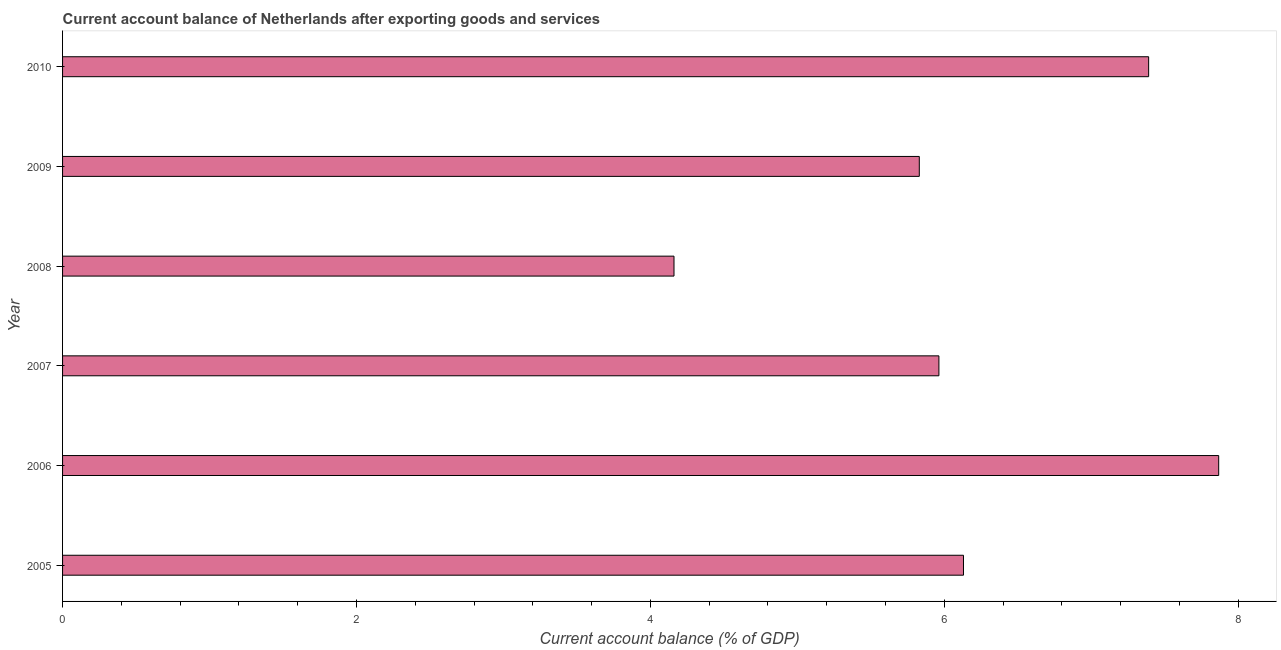What is the title of the graph?
Make the answer very short. Current account balance of Netherlands after exporting goods and services. What is the label or title of the X-axis?
Give a very brief answer. Current account balance (% of GDP). What is the label or title of the Y-axis?
Offer a terse response. Year. What is the current account balance in 2007?
Provide a succinct answer. 5.96. Across all years, what is the maximum current account balance?
Your answer should be very brief. 7.87. Across all years, what is the minimum current account balance?
Your answer should be very brief. 4.16. What is the sum of the current account balance?
Your response must be concise. 37.34. What is the difference between the current account balance in 2006 and 2008?
Offer a very short reply. 3.71. What is the average current account balance per year?
Your answer should be compact. 6.22. What is the median current account balance?
Your answer should be compact. 6.05. In how many years, is the current account balance greater than 5.6 %?
Your answer should be compact. 5. What is the ratio of the current account balance in 2005 to that in 2010?
Ensure brevity in your answer.  0.83. Is the current account balance in 2005 less than that in 2008?
Offer a very short reply. No. What is the difference between the highest and the second highest current account balance?
Offer a very short reply. 0.48. What is the difference between the highest and the lowest current account balance?
Ensure brevity in your answer.  3.71. How many bars are there?
Give a very brief answer. 6. How many years are there in the graph?
Provide a short and direct response. 6. What is the difference between two consecutive major ticks on the X-axis?
Your answer should be very brief. 2. What is the Current account balance (% of GDP) of 2005?
Make the answer very short. 6.13. What is the Current account balance (% of GDP) in 2006?
Offer a terse response. 7.87. What is the Current account balance (% of GDP) in 2007?
Your response must be concise. 5.96. What is the Current account balance (% of GDP) of 2008?
Offer a terse response. 4.16. What is the Current account balance (% of GDP) in 2009?
Your response must be concise. 5.83. What is the Current account balance (% of GDP) of 2010?
Provide a short and direct response. 7.39. What is the difference between the Current account balance (% of GDP) in 2005 and 2006?
Offer a terse response. -1.74. What is the difference between the Current account balance (% of GDP) in 2005 and 2007?
Your answer should be compact. 0.17. What is the difference between the Current account balance (% of GDP) in 2005 and 2008?
Give a very brief answer. 1.97. What is the difference between the Current account balance (% of GDP) in 2005 and 2009?
Your answer should be compact. 0.3. What is the difference between the Current account balance (% of GDP) in 2005 and 2010?
Provide a short and direct response. -1.26. What is the difference between the Current account balance (% of GDP) in 2006 and 2007?
Your answer should be very brief. 1.9. What is the difference between the Current account balance (% of GDP) in 2006 and 2008?
Keep it short and to the point. 3.71. What is the difference between the Current account balance (% of GDP) in 2006 and 2009?
Your answer should be compact. 2.04. What is the difference between the Current account balance (% of GDP) in 2006 and 2010?
Keep it short and to the point. 0.48. What is the difference between the Current account balance (% of GDP) in 2007 and 2008?
Offer a terse response. 1.8. What is the difference between the Current account balance (% of GDP) in 2007 and 2009?
Provide a succinct answer. 0.13. What is the difference between the Current account balance (% of GDP) in 2007 and 2010?
Provide a succinct answer. -1.43. What is the difference between the Current account balance (% of GDP) in 2008 and 2009?
Keep it short and to the point. -1.67. What is the difference between the Current account balance (% of GDP) in 2008 and 2010?
Make the answer very short. -3.23. What is the difference between the Current account balance (% of GDP) in 2009 and 2010?
Provide a succinct answer. -1.56. What is the ratio of the Current account balance (% of GDP) in 2005 to that in 2006?
Provide a succinct answer. 0.78. What is the ratio of the Current account balance (% of GDP) in 2005 to that in 2007?
Your answer should be very brief. 1.03. What is the ratio of the Current account balance (% of GDP) in 2005 to that in 2008?
Offer a very short reply. 1.47. What is the ratio of the Current account balance (% of GDP) in 2005 to that in 2009?
Provide a succinct answer. 1.05. What is the ratio of the Current account balance (% of GDP) in 2005 to that in 2010?
Provide a succinct answer. 0.83. What is the ratio of the Current account balance (% of GDP) in 2006 to that in 2007?
Your answer should be compact. 1.32. What is the ratio of the Current account balance (% of GDP) in 2006 to that in 2008?
Keep it short and to the point. 1.89. What is the ratio of the Current account balance (% of GDP) in 2006 to that in 2009?
Provide a succinct answer. 1.35. What is the ratio of the Current account balance (% of GDP) in 2006 to that in 2010?
Provide a short and direct response. 1.06. What is the ratio of the Current account balance (% of GDP) in 2007 to that in 2008?
Provide a succinct answer. 1.43. What is the ratio of the Current account balance (% of GDP) in 2007 to that in 2009?
Your answer should be very brief. 1.02. What is the ratio of the Current account balance (% of GDP) in 2007 to that in 2010?
Offer a terse response. 0.81. What is the ratio of the Current account balance (% of GDP) in 2008 to that in 2009?
Make the answer very short. 0.71. What is the ratio of the Current account balance (% of GDP) in 2008 to that in 2010?
Offer a terse response. 0.56. What is the ratio of the Current account balance (% of GDP) in 2009 to that in 2010?
Your answer should be very brief. 0.79. 